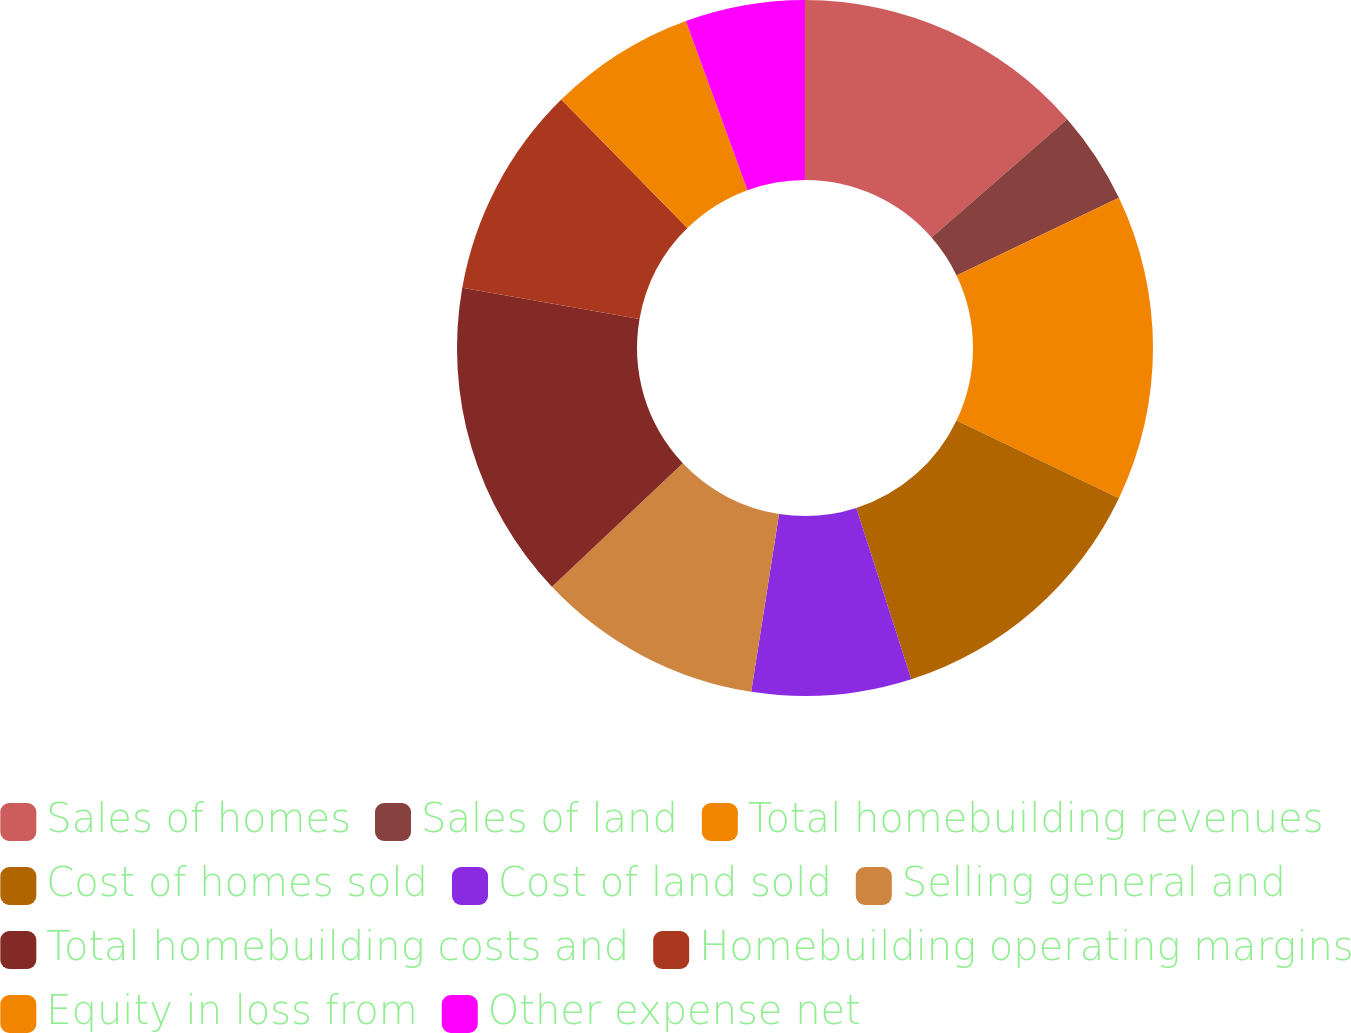Convert chart. <chart><loc_0><loc_0><loc_500><loc_500><pie_chart><fcel>Sales of homes<fcel>Sales of land<fcel>Total homebuilding revenues<fcel>Cost of homes sold<fcel>Cost of land sold<fcel>Selling general and<fcel>Total homebuilding costs and<fcel>Homebuilding operating margins<fcel>Equity in loss from<fcel>Other expense net<nl><fcel>13.58%<fcel>4.32%<fcel>14.2%<fcel>12.96%<fcel>7.41%<fcel>10.49%<fcel>14.81%<fcel>9.88%<fcel>6.79%<fcel>5.56%<nl></chart> 